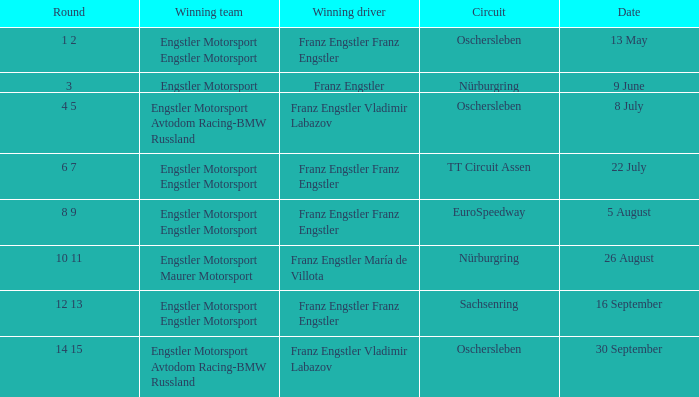What Round was the Winning Team Engstler Motorsport Maurer Motorsport? 10 11. Help me parse the entirety of this table. {'header': ['Round', 'Winning team', 'Winning driver', 'Circuit', 'Date'], 'rows': [['1 2', 'Engstler Motorsport Engstler Motorsport', 'Franz Engstler Franz Engstler', 'Oschersleben', '13 May'], ['3', 'Engstler Motorsport', 'Franz Engstler', 'Nürburgring', '9 June'], ['4 5', 'Engstler Motorsport Avtodom Racing-BMW Russland', 'Franz Engstler Vladimir Labazov', 'Oschersleben', '8 July'], ['6 7', 'Engstler Motorsport Engstler Motorsport', 'Franz Engstler Franz Engstler', 'TT Circuit Assen', '22 July'], ['8 9', 'Engstler Motorsport Engstler Motorsport', 'Franz Engstler Franz Engstler', 'EuroSpeedway', '5 August'], ['10 11', 'Engstler Motorsport Maurer Motorsport', 'Franz Engstler María de Villota', 'Nürburgring', '26 August'], ['12 13', 'Engstler Motorsport Engstler Motorsport', 'Franz Engstler Franz Engstler', 'Sachsenring', '16 September'], ['14 15', 'Engstler Motorsport Avtodom Racing-BMW Russland', 'Franz Engstler Vladimir Labazov', 'Oschersleben', '30 September']]} 